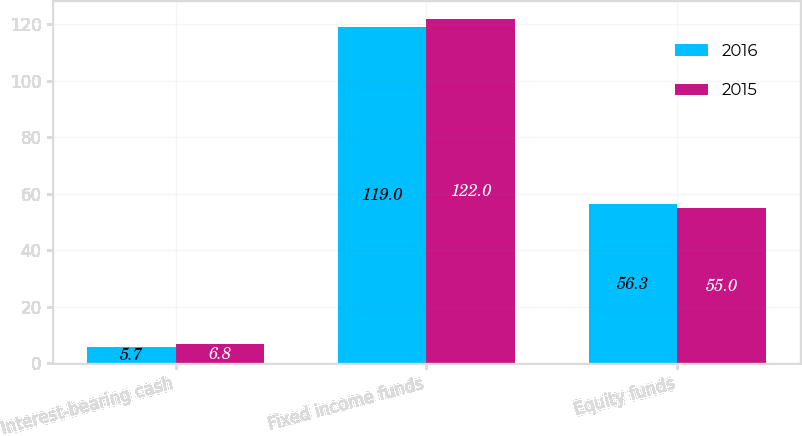Convert chart to OTSL. <chart><loc_0><loc_0><loc_500><loc_500><stacked_bar_chart><ecel><fcel>Interest-bearing cash<fcel>Fixed income funds<fcel>Equity funds<nl><fcel>2016<fcel>5.7<fcel>119<fcel>56.3<nl><fcel>2015<fcel>6.8<fcel>122<fcel>55<nl></chart> 